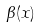Convert formula to latex. <formula><loc_0><loc_0><loc_500><loc_500>\beta ( x )</formula> 